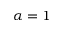<formula> <loc_0><loc_0><loc_500><loc_500>\alpha = 1</formula> 